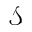Convert formula to latex. <formula><loc_0><loc_0><loc_500><loc_500>\mathcal { S }</formula> 